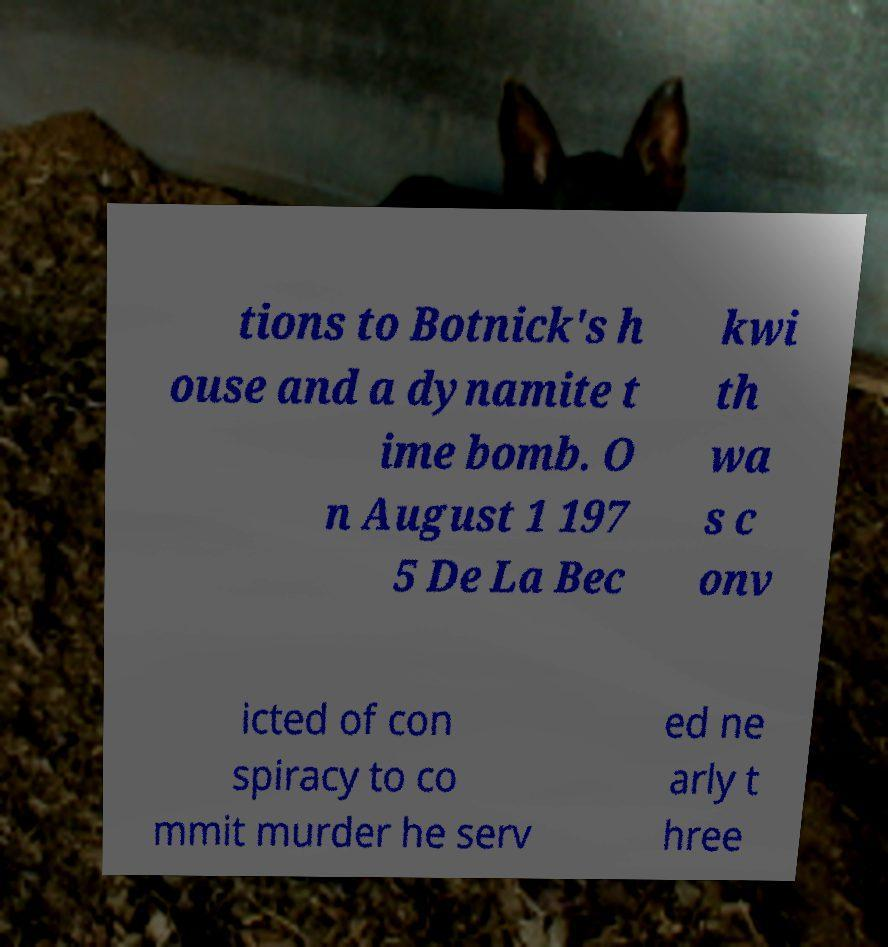Could you extract and type out the text from this image? tions to Botnick's h ouse and a dynamite t ime bomb. O n August 1 197 5 De La Bec kwi th wa s c onv icted of con spiracy to co mmit murder he serv ed ne arly t hree 